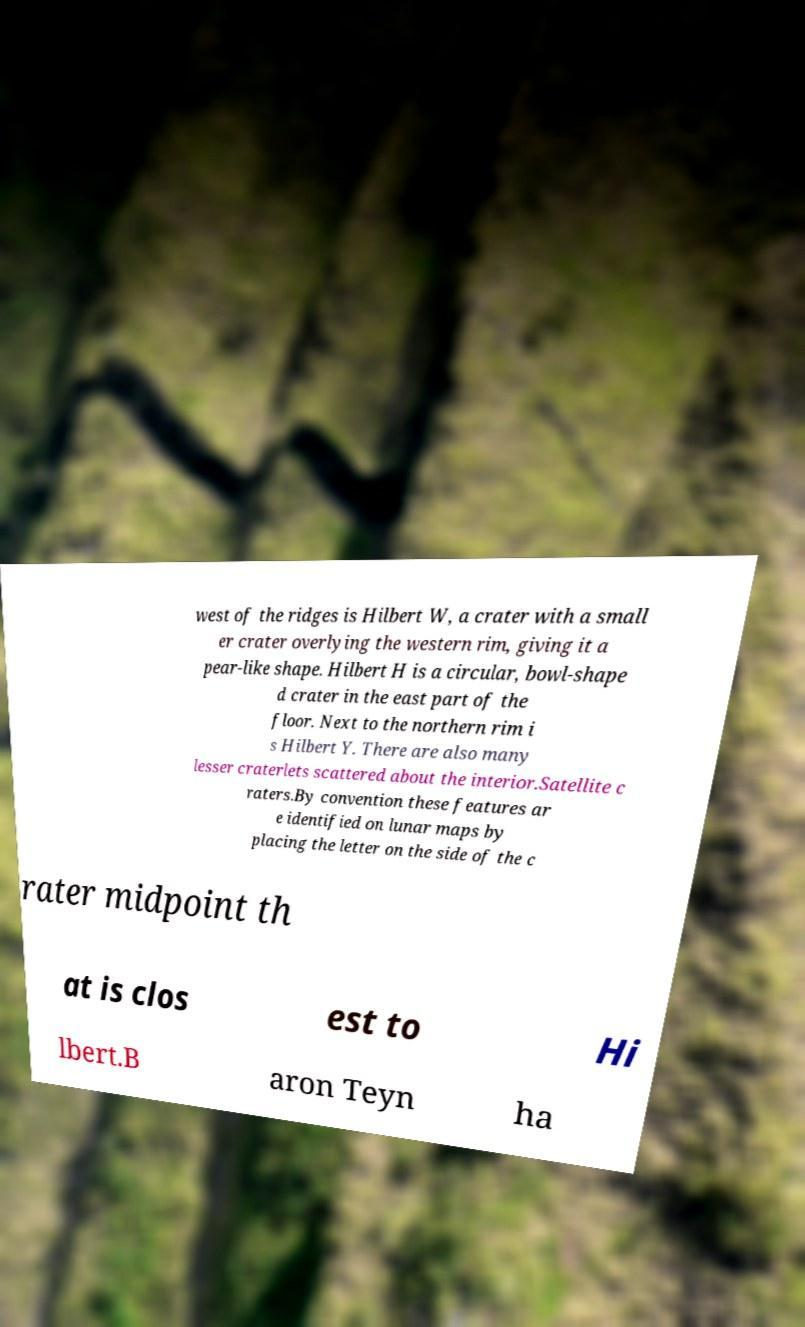For documentation purposes, I need the text within this image transcribed. Could you provide that? west of the ridges is Hilbert W, a crater with a small er crater overlying the western rim, giving it a pear-like shape. Hilbert H is a circular, bowl-shape d crater in the east part of the floor. Next to the northern rim i s Hilbert Y. There are also many lesser craterlets scattered about the interior.Satellite c raters.By convention these features ar e identified on lunar maps by placing the letter on the side of the c rater midpoint th at is clos est to Hi lbert.B aron Teyn ha 